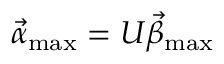<formula> <loc_0><loc_0><loc_500><loc_500>\vec { \alpha } _ { \max } = U \vec { \beta } _ { \max }</formula> 